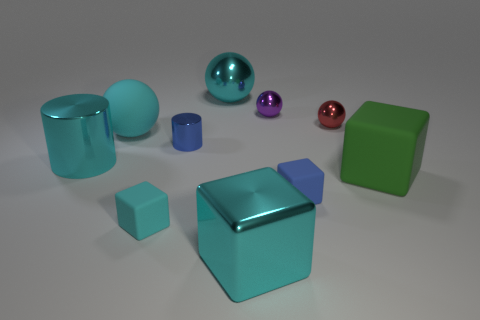The big metallic object that is the same shape as the blue matte object is what color?
Ensure brevity in your answer.  Cyan. There is a big rubber ball that is behind the cyan metal cylinder; does it have the same color as the big rubber block?
Your response must be concise. No. What number of balls are there?
Provide a succinct answer. 4. Is the big object in front of the green matte thing made of the same material as the big cylinder?
Keep it short and to the point. Yes. Is there any other thing that has the same material as the tiny cylinder?
Keep it short and to the point. Yes. How many cyan rubber objects are behind the blue metallic thing behind the rubber block that is in front of the blue matte object?
Your answer should be compact. 1. The cyan metallic cylinder is what size?
Your response must be concise. Large. Is the big metal cylinder the same color as the large metallic block?
Your response must be concise. Yes. There is a cyan rubber sphere in front of the big metal ball; how big is it?
Keep it short and to the point. Large. Do the big matte thing behind the green thing and the tiny rubber block that is in front of the blue block have the same color?
Offer a very short reply. Yes. 